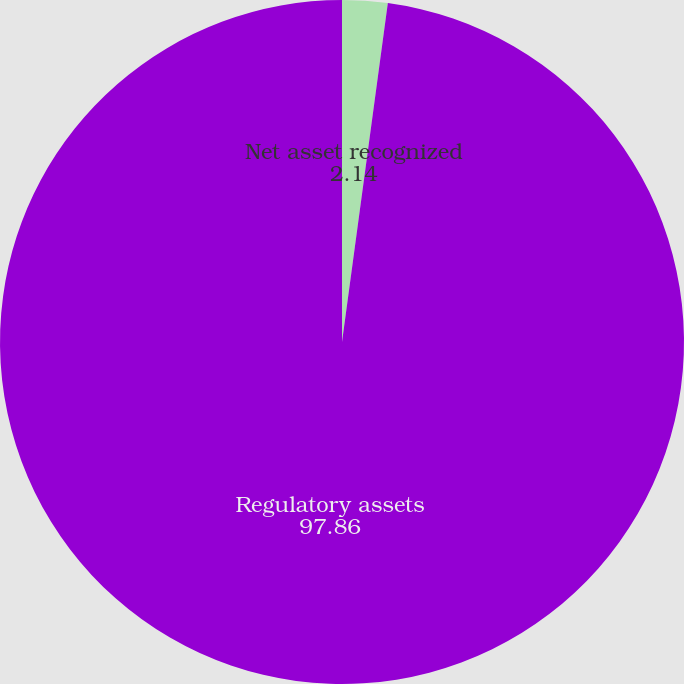Convert chart to OTSL. <chart><loc_0><loc_0><loc_500><loc_500><pie_chart><fcel>Net asset recognized<fcel>Regulatory assets<nl><fcel>2.14%<fcel>97.86%<nl></chart> 